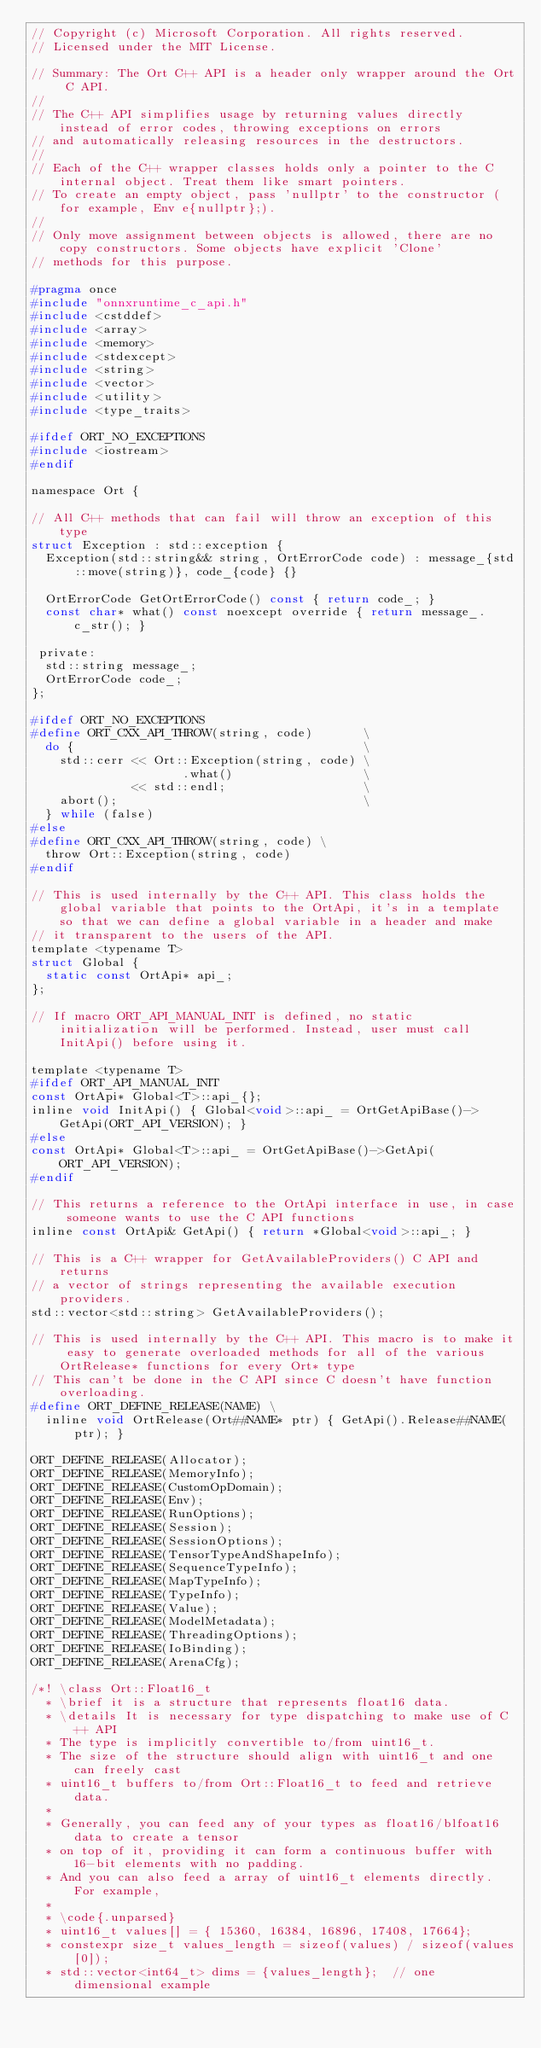<code> <loc_0><loc_0><loc_500><loc_500><_C_>// Copyright (c) Microsoft Corporation. All rights reserved.
// Licensed under the MIT License.

// Summary: The Ort C++ API is a header only wrapper around the Ort C API.
//
// The C++ API simplifies usage by returning values directly instead of error codes, throwing exceptions on errors
// and automatically releasing resources in the destructors.
//
// Each of the C++ wrapper classes holds only a pointer to the C internal object. Treat them like smart pointers.
// To create an empty object, pass 'nullptr' to the constructor (for example, Env e{nullptr};).
//
// Only move assignment between objects is allowed, there are no copy constructors. Some objects have explicit 'Clone'
// methods for this purpose.

#pragma once
#include "onnxruntime_c_api.h"
#include <cstddef>
#include <array>
#include <memory>
#include <stdexcept>
#include <string>
#include <vector>
#include <utility>
#include <type_traits>

#ifdef ORT_NO_EXCEPTIONS
#include <iostream>
#endif

namespace Ort {

// All C++ methods that can fail will throw an exception of this type
struct Exception : std::exception {
  Exception(std::string&& string, OrtErrorCode code) : message_{std::move(string)}, code_{code} {}

  OrtErrorCode GetOrtErrorCode() const { return code_; }
  const char* what() const noexcept override { return message_.c_str(); }

 private:
  std::string message_;
  OrtErrorCode code_;
};

#ifdef ORT_NO_EXCEPTIONS
#define ORT_CXX_API_THROW(string, code)       \
  do {                                        \
    std::cerr << Ort::Exception(string, code) \
                     .what()                  \
              << std::endl;                   \
    abort();                                  \
  } while (false)
#else
#define ORT_CXX_API_THROW(string, code) \
  throw Ort::Exception(string, code)
#endif

// This is used internally by the C++ API. This class holds the global variable that points to the OrtApi, it's in a template so that we can define a global variable in a header and make
// it transparent to the users of the API.
template <typename T>
struct Global {
  static const OrtApi* api_;
};

// If macro ORT_API_MANUAL_INIT is defined, no static initialization will be performed. Instead, user must call InitApi() before using it.

template <typename T>
#ifdef ORT_API_MANUAL_INIT
const OrtApi* Global<T>::api_{};
inline void InitApi() { Global<void>::api_ = OrtGetApiBase()->GetApi(ORT_API_VERSION); }
#else
const OrtApi* Global<T>::api_ = OrtGetApiBase()->GetApi(ORT_API_VERSION);
#endif

// This returns a reference to the OrtApi interface in use, in case someone wants to use the C API functions
inline const OrtApi& GetApi() { return *Global<void>::api_; }

// This is a C++ wrapper for GetAvailableProviders() C API and returns
// a vector of strings representing the available execution providers.
std::vector<std::string> GetAvailableProviders();

// This is used internally by the C++ API. This macro is to make it easy to generate overloaded methods for all of the various OrtRelease* functions for every Ort* type
// This can't be done in the C API since C doesn't have function overloading.
#define ORT_DEFINE_RELEASE(NAME) \
  inline void OrtRelease(Ort##NAME* ptr) { GetApi().Release##NAME(ptr); }

ORT_DEFINE_RELEASE(Allocator);
ORT_DEFINE_RELEASE(MemoryInfo);
ORT_DEFINE_RELEASE(CustomOpDomain);
ORT_DEFINE_RELEASE(Env);
ORT_DEFINE_RELEASE(RunOptions);
ORT_DEFINE_RELEASE(Session);
ORT_DEFINE_RELEASE(SessionOptions);
ORT_DEFINE_RELEASE(TensorTypeAndShapeInfo);
ORT_DEFINE_RELEASE(SequenceTypeInfo);
ORT_DEFINE_RELEASE(MapTypeInfo);
ORT_DEFINE_RELEASE(TypeInfo);
ORT_DEFINE_RELEASE(Value);
ORT_DEFINE_RELEASE(ModelMetadata);
ORT_DEFINE_RELEASE(ThreadingOptions);
ORT_DEFINE_RELEASE(IoBinding);
ORT_DEFINE_RELEASE(ArenaCfg);

/*! \class Ort::Float16_t
  * \brief it is a structure that represents float16 data.
  * \details It is necessary for type dispatching to make use of C++ API
  * The type is implicitly convertible to/from uint16_t.
  * The size of the structure should align with uint16_t and one can freely cast
  * uint16_t buffers to/from Ort::Float16_t to feed and retrieve data.
  * 
  * Generally, you can feed any of your types as float16/blfoat16 data to create a tensor
  * on top of it, providing it can form a continuous buffer with 16-bit elements with no padding.
  * And you can also feed a array of uint16_t elements directly. For example,
  * 
  * \code{.unparsed}
  * uint16_t values[] = { 15360, 16384, 16896, 17408, 17664};
  * constexpr size_t values_length = sizeof(values) / sizeof(values[0]);
  * std::vector<int64_t> dims = {values_length};  // one dimensional example</code> 